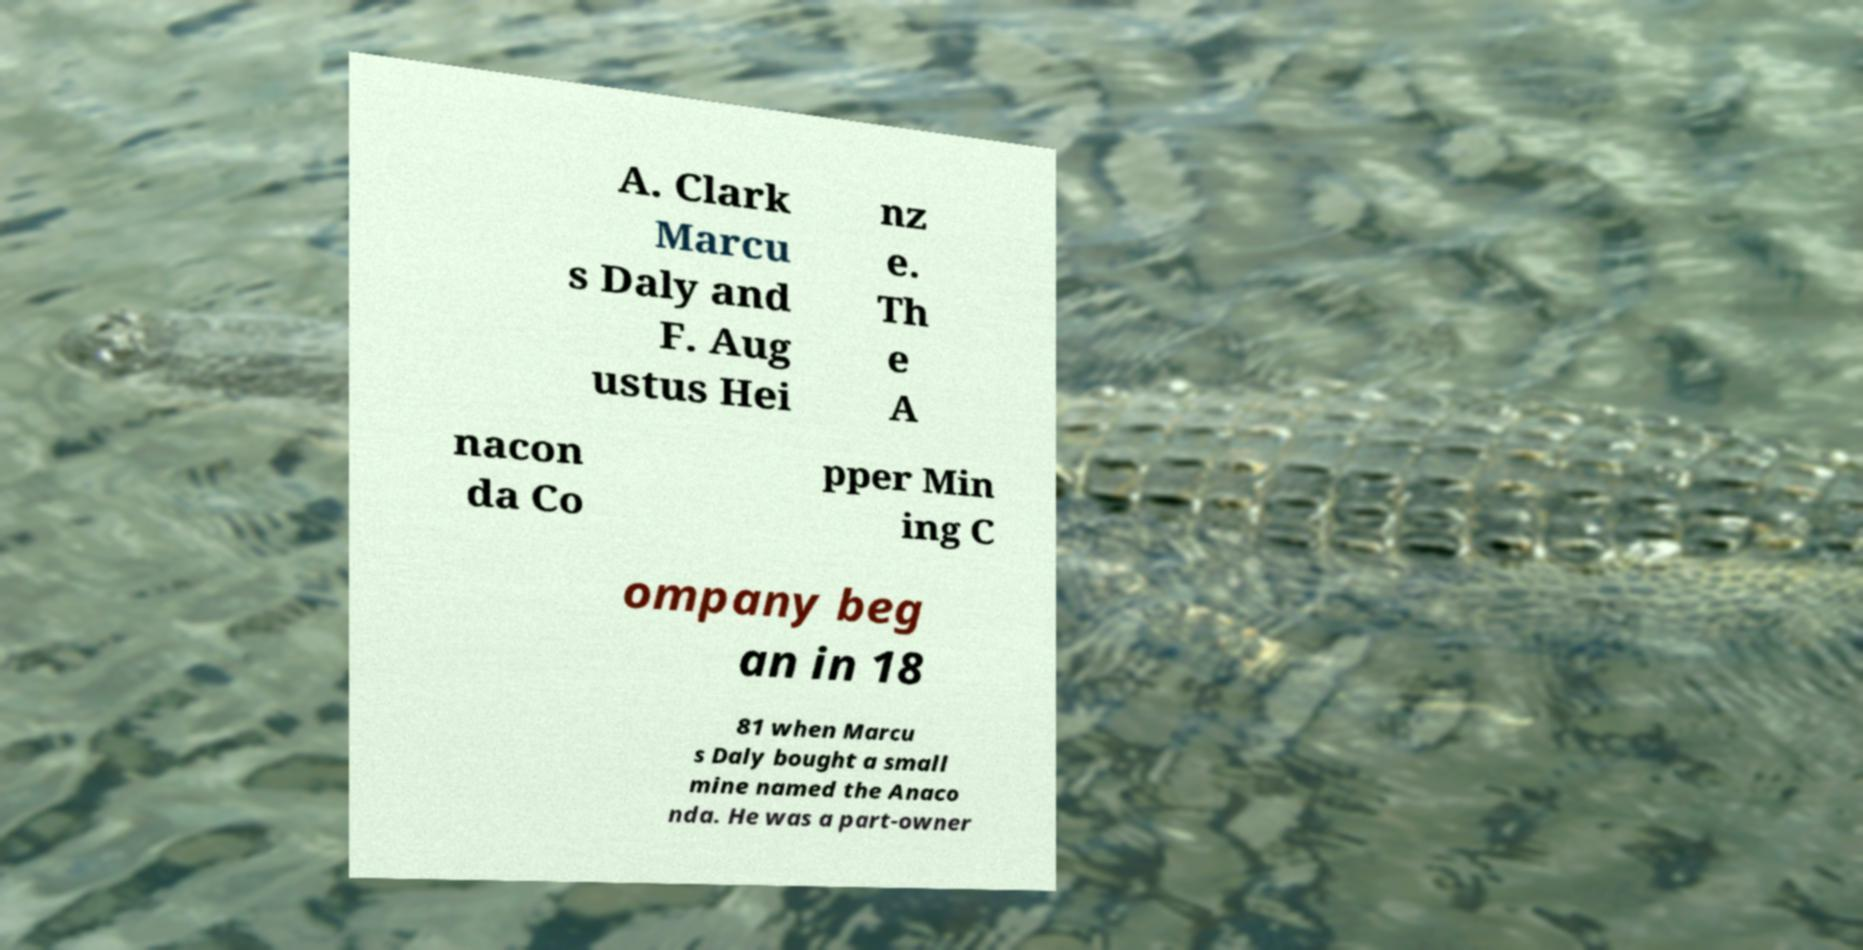Can you accurately transcribe the text from the provided image for me? A. Clark Marcu s Daly and F. Aug ustus Hei nz e. Th e A nacon da Co pper Min ing C ompany beg an in 18 81 when Marcu s Daly bought a small mine named the Anaco nda. He was a part-owner 